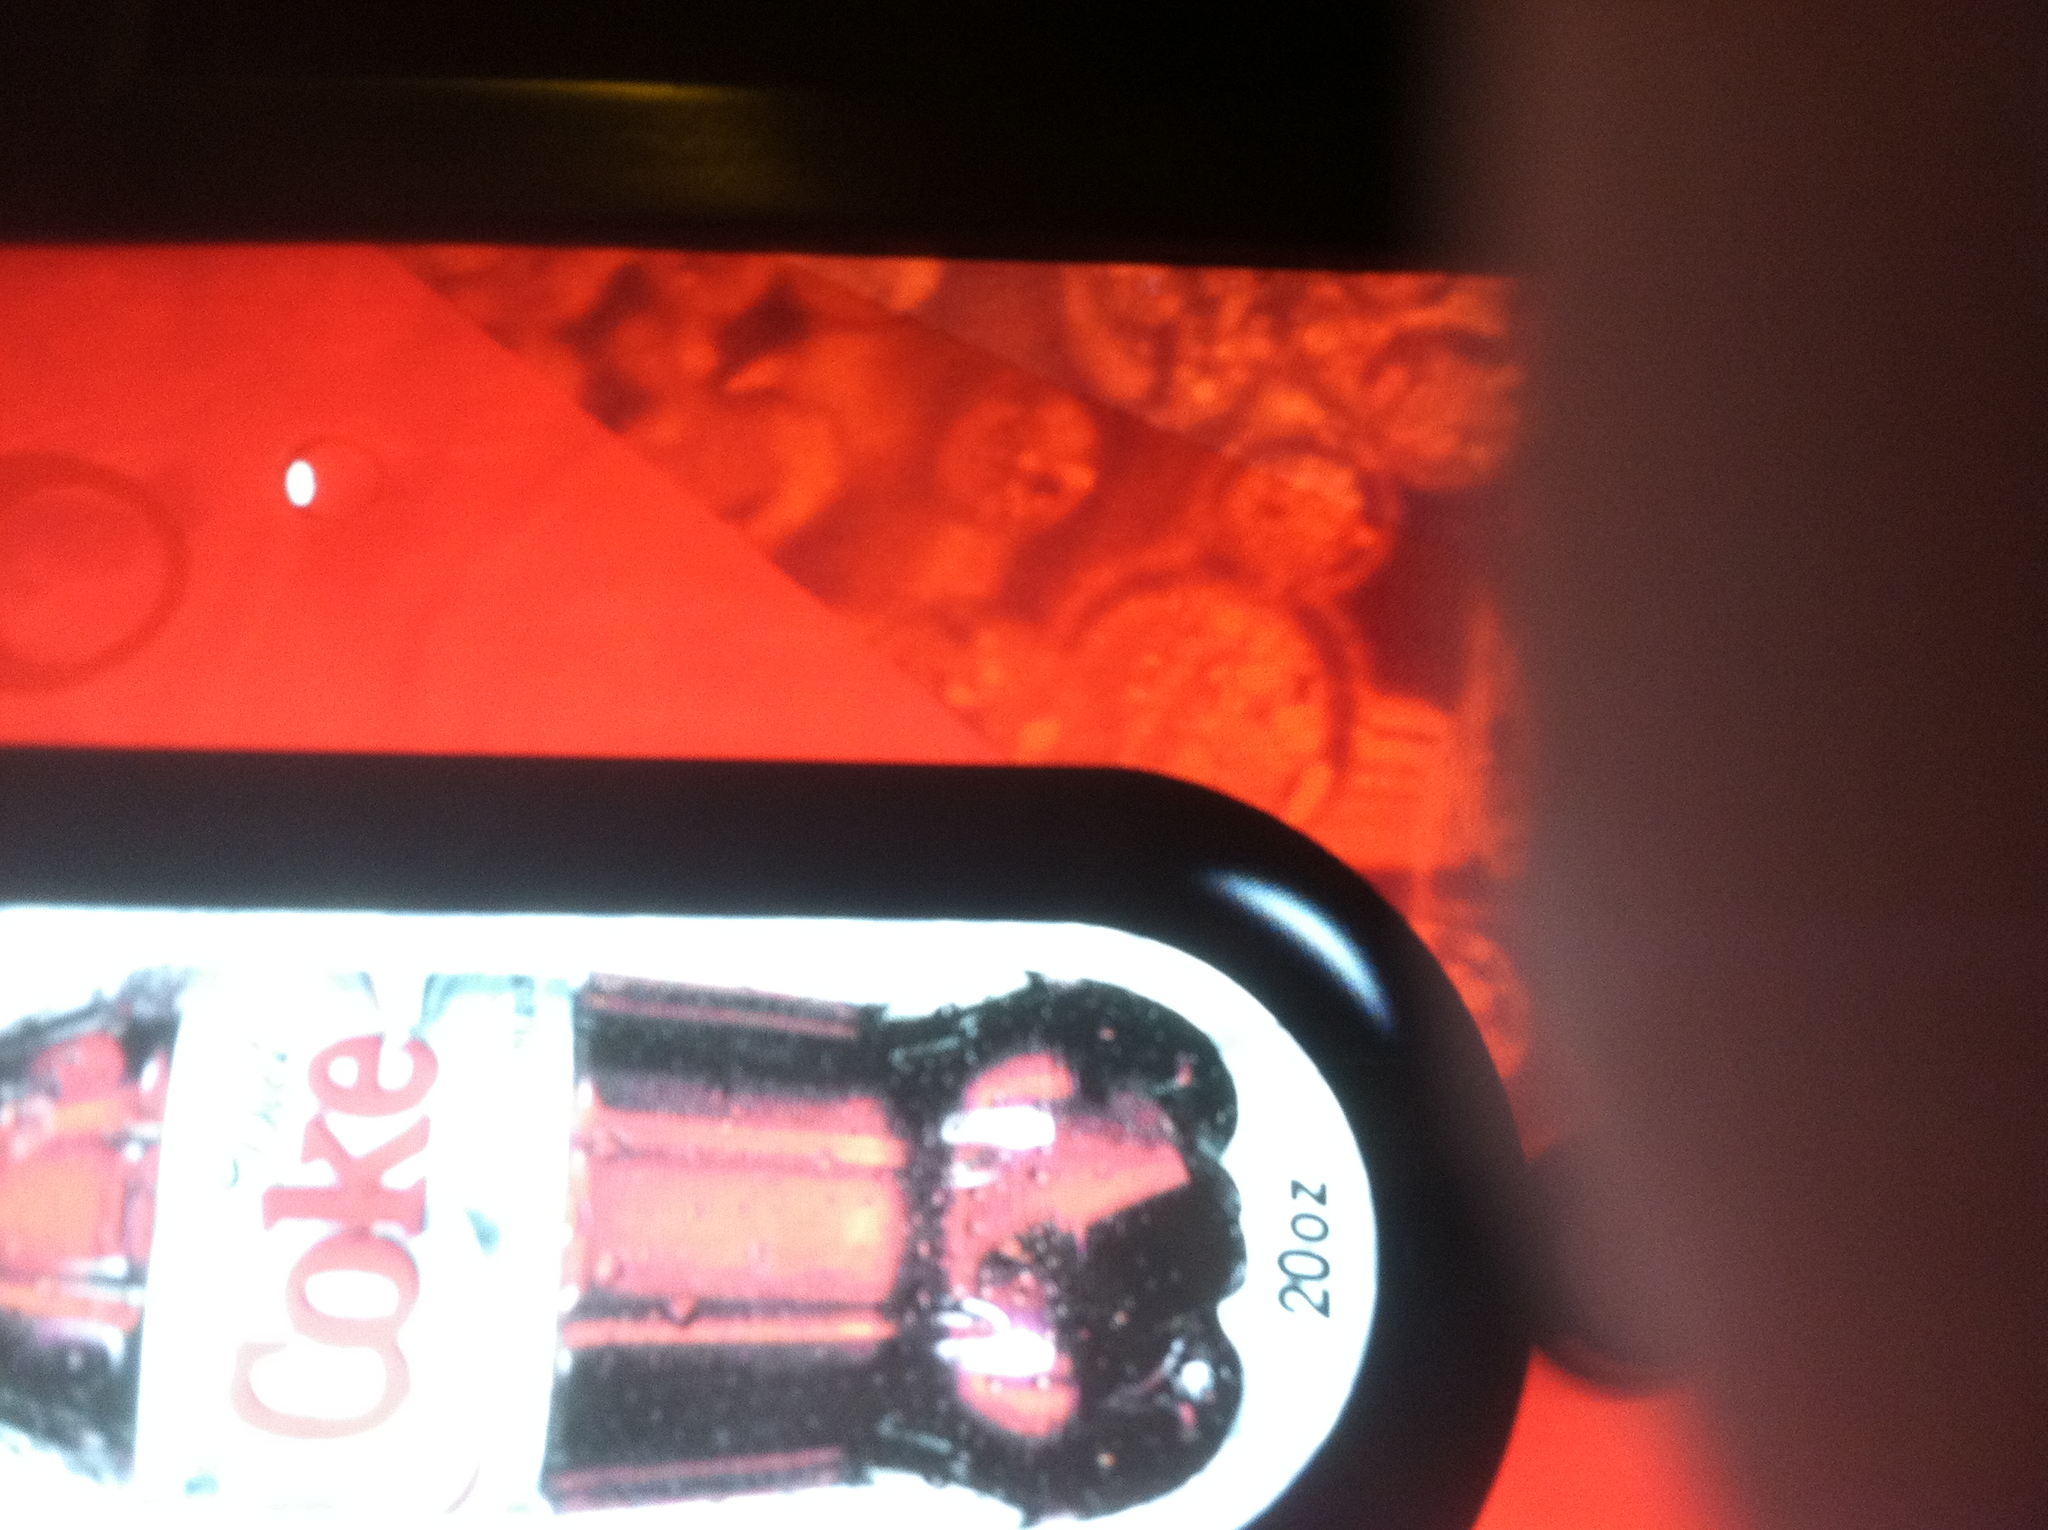What flavor coke does this button belong to? The button depicted in the image belongs to Diet Coke. You can tell by the distinctive label and packaging, which is characteristic of Diet Coke bottles. 